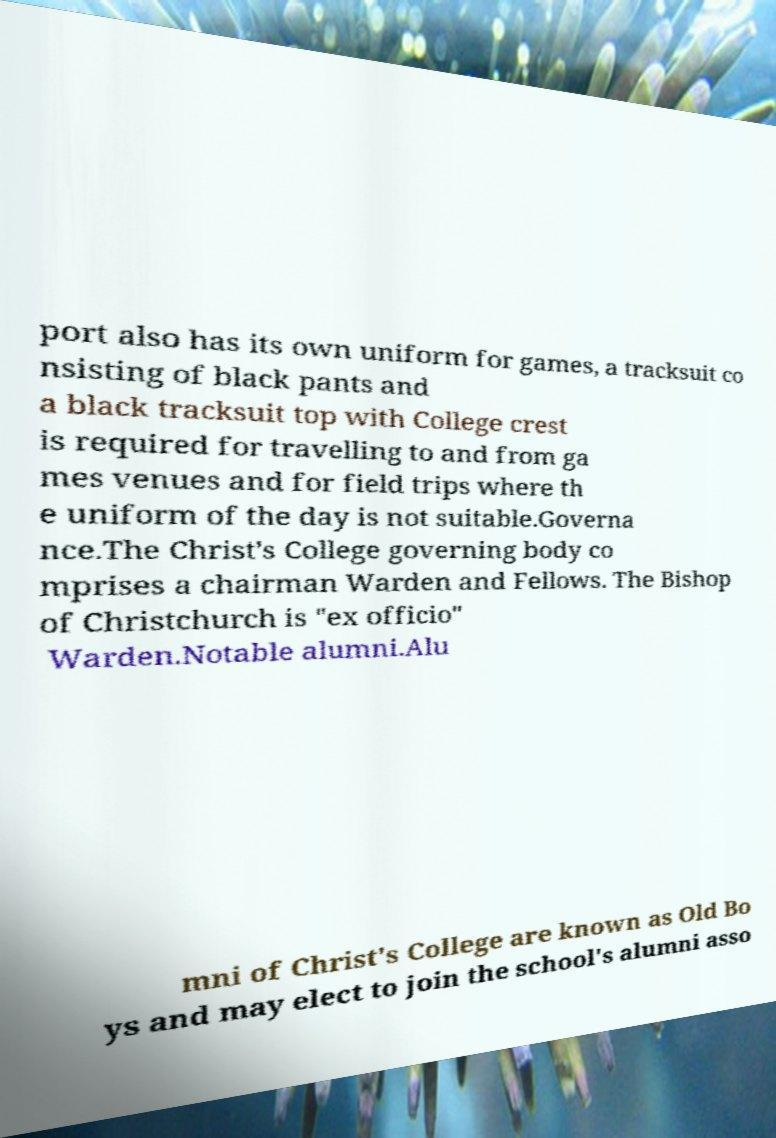What messages or text are displayed in this image? I need them in a readable, typed format. port also has its own uniform for games, a tracksuit co nsisting of black pants and a black tracksuit top with College crest is required for travelling to and from ga mes venues and for field trips where th e uniform of the day is not suitable.Governa nce.The Christ's College governing body co mprises a chairman Warden and Fellows. The Bishop of Christchurch is "ex officio" Warden.Notable alumni.Alu mni of Christ's College are known as Old Bo ys and may elect to join the school's alumni asso 